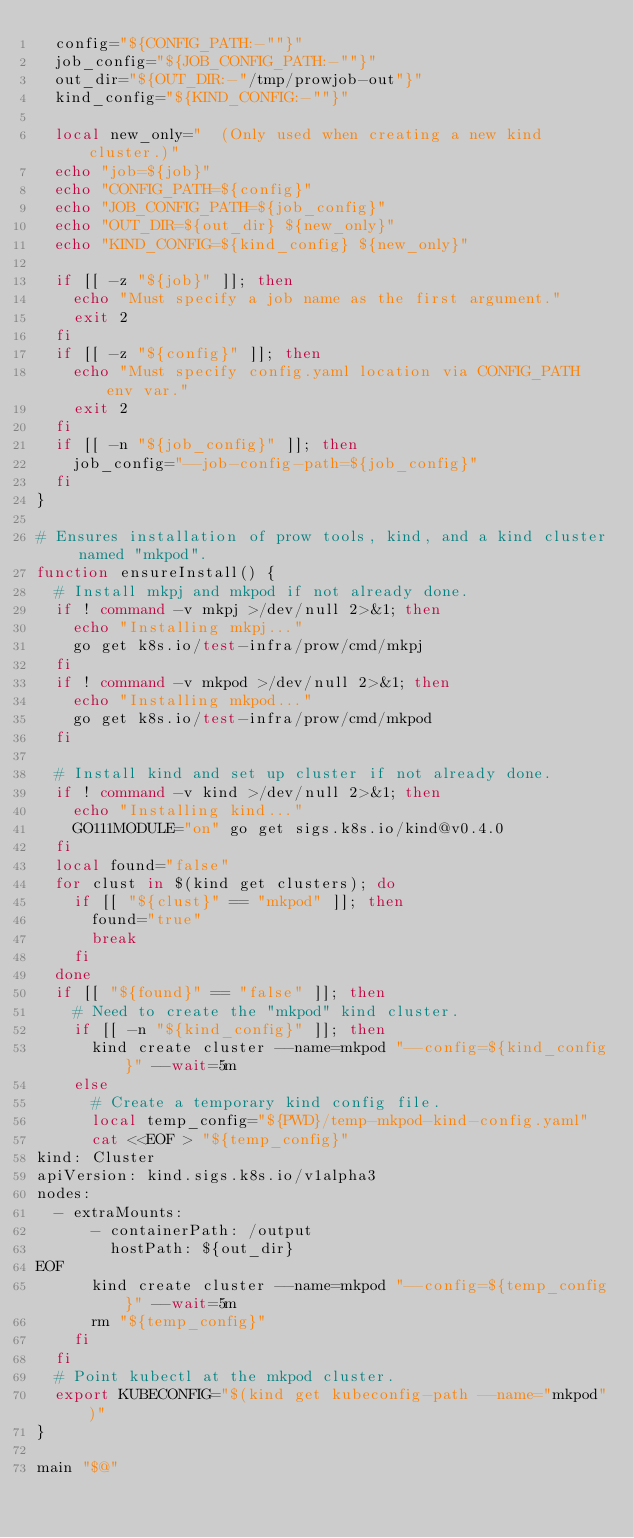<code> <loc_0><loc_0><loc_500><loc_500><_Bash_>  config="${CONFIG_PATH:-""}"
  job_config="${JOB_CONFIG_PATH:-""}"
  out_dir="${OUT_DIR:-"/tmp/prowjob-out"}"
  kind_config="${KIND_CONFIG:-""}"

  local new_only="  (Only used when creating a new kind cluster.)"
  echo "job=${job}"
  echo "CONFIG_PATH=${config}"
  echo "JOB_CONFIG_PATH=${job_config}"
  echo "OUT_DIR=${out_dir} ${new_only}"
  echo "KIND_CONFIG=${kind_config} ${new_only}"

  if [[ -z "${job}" ]]; then
    echo "Must specify a job name as the first argument."
    exit 2
  fi
  if [[ -z "${config}" ]]; then
    echo "Must specify config.yaml location via CONFIG_PATH env var."
    exit 2
  fi
  if [[ -n "${job_config}" ]]; then
    job_config="--job-config-path=${job_config}"
  fi
}

# Ensures installation of prow tools, kind, and a kind cluster named "mkpod".
function ensureInstall() {
  # Install mkpj and mkpod if not already done.
  if ! command -v mkpj >/dev/null 2>&1; then
    echo "Installing mkpj..."
    go get k8s.io/test-infra/prow/cmd/mkpj
  fi
  if ! command -v mkpod >/dev/null 2>&1; then
    echo "Installing mkpod..."
    go get k8s.io/test-infra/prow/cmd/mkpod
  fi

  # Install kind and set up cluster if not already done.
  if ! command -v kind >/dev/null 2>&1; then
    echo "Installing kind..."
    GO111MODULE="on" go get sigs.k8s.io/kind@v0.4.0
  fi
  local found="false"
  for clust in $(kind get clusters); do
    if [[ "${clust}" == "mkpod" ]]; then
      found="true"
      break
    fi
  done
  if [[ "${found}" == "false" ]]; then
    # Need to create the "mkpod" kind cluster.
    if [[ -n "${kind_config}" ]]; then
      kind create cluster --name=mkpod "--config=${kind_config}" --wait=5m
    else
      # Create a temporary kind config file.
      local temp_config="${PWD}/temp-mkpod-kind-config.yaml"
      cat <<EOF > "${temp_config}"
kind: Cluster
apiVersion: kind.sigs.k8s.io/v1alpha3
nodes:
  - extraMounts:
      - containerPath: /output
        hostPath: ${out_dir}
EOF
      kind create cluster --name=mkpod "--config=${temp_config}" --wait=5m
      rm "${temp_config}"
    fi
  fi
  # Point kubectl at the mkpod cluster.
  export KUBECONFIG="$(kind get kubeconfig-path --name="mkpod")"
}

main "$@"</code> 